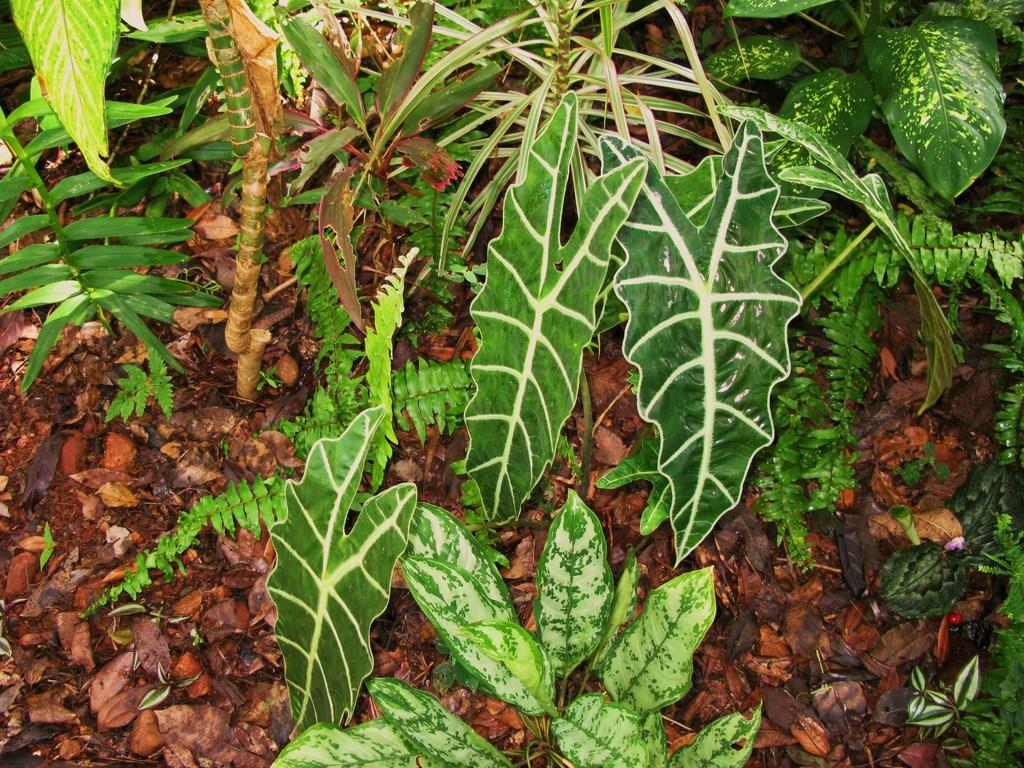What type of living organisms are in the image? The image contains plants. What can be seen at the bottom of the image? There are dried leaves at the bottom of the image. What type of hydrant can be seen in the image? There is no hydrant present in the image. How does the stomach of the plant appear in the image? There is no representation of a plant's stomach in the image, as plants do not have stomachs. 